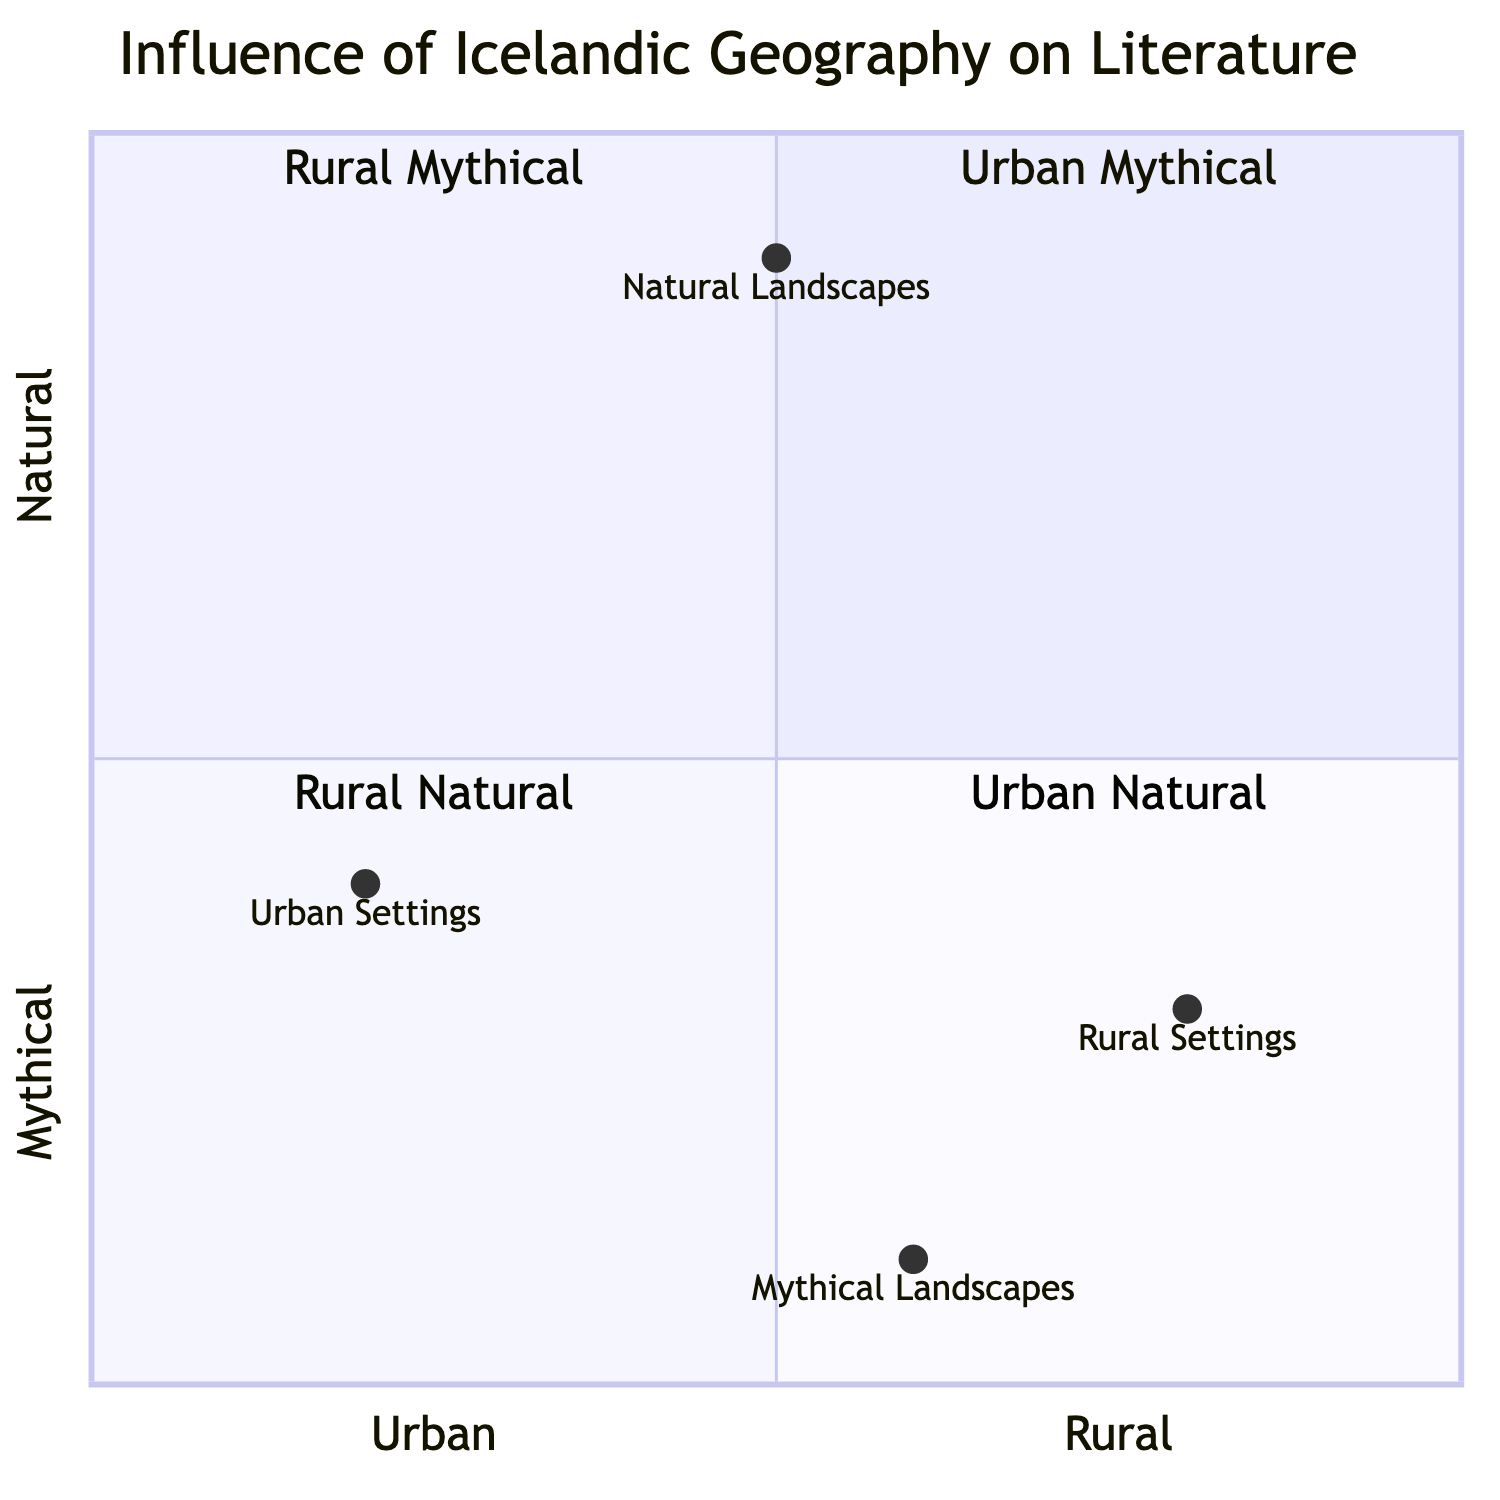What is the position of Urban Settings in the chart? Urban Settings is located at coordinates [0.2, 0.4] in the chart, indicating that it is positioned more towards the urban side on the x-axis and slightly lower on the mythical side of the y-axis.
Answer: [0.2, 0.4] Which quadrant contains Natural Landscapes? Natural Landscapes are positioned at [0.5, 0.9], which places it in the fourth quadrant (Urban Natural), based on the coordinates being in the upper left of the quadrant grid.
Answer: Quadrant 4 (Urban Natural) What is the value of the Rural Settings on the y-axis? The y-value for Rural Settings is 0.3 as per the coordinates [0.8, 0.3]. This indicates its position in relation to mythical and natural landscapes.
Answer: 0.3 How many elements are in the Urban Mythical quadrant? According to the quadrant data, there is one element explicitly categorized as Urban Mythical, which is Urban Settings.
Answer: 1 Which element is closest to the origin of the chart? Urban Settings at [0.2, 0.4] is the closest element to the origin (0,0) when comparing the distances of other elements from the origin.
Answer: Urban Settings Which two elements have the highest y-values? Natural Landscapes at y = 0.9 and Rural Settings at y = 0.3 are the two highest in the y-values, with Natural Landscapes having the highest overall.
Answer: Natural Landscapes, Rural Settings What is the description of Mythical Landscapes? Mythical Landscapes is defined as the incorporation of Icelandic mythology and legendary settings in literature. This is evident from the examples given in the chart.
Answer: Incorporation of Icelandic mythology and legendary settings Are there more elements in the Natural Landscapes category than in the Mythical Landscapes category? Natural Landscapes has three examples, whereas Mythical Landscapes also has three. Therefore, both categories contain an equal number of elements.
Answer: No 